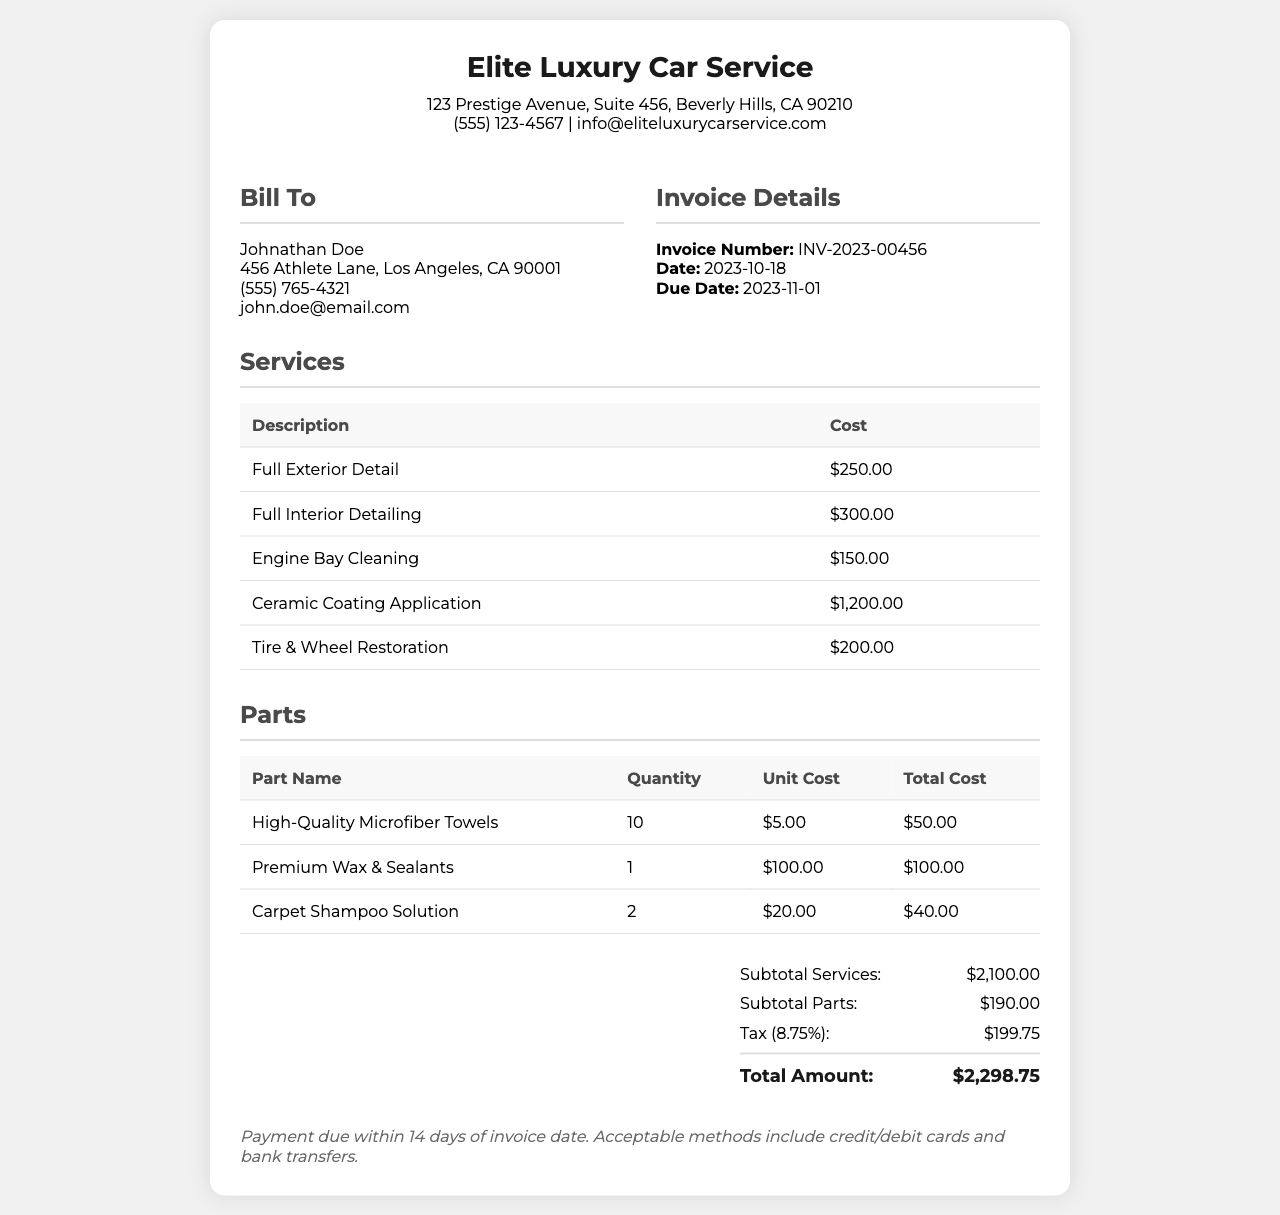What is the invoice number? The invoice number is specified in the document under 'Invoice Details'.
Answer: INV-2023-00456 What is the total amount due? The total amount is calculated from the subtotals and tax included in the summary section.
Answer: $2,298.75 Who is the customer for this invoice? The customer's name is listed at the top of the 'Bill To' section.
Answer: Johnathan Doe What is the date of the invoice? The date of the invoice is provided in the invoice details.
Answer: 2023-10-18 How much does the Ceramic Coating Application cost? The cost for Ceramic Coating Application is detailed in the services section of the document.
Answer: $1,200.00 What is the total cost of the high-quality microfiber towels? The total cost can be found in the parts table, calculated by quantity and unit cost.
Answer: $50.00 What percentage is the tax applied in this invoice? The tax percentage is mentioned in the summary section of the invoice.
Answer: 8.75% How many types of services are listed in the invoice? The number of different services listed can be counted from the services table.
Answer: 5 What are the payment terms specified in the invoice? The payment terms are mentioned at the end of the document, indicating due time and method of payment.
Answer: Payment due within 14 days of invoice date 